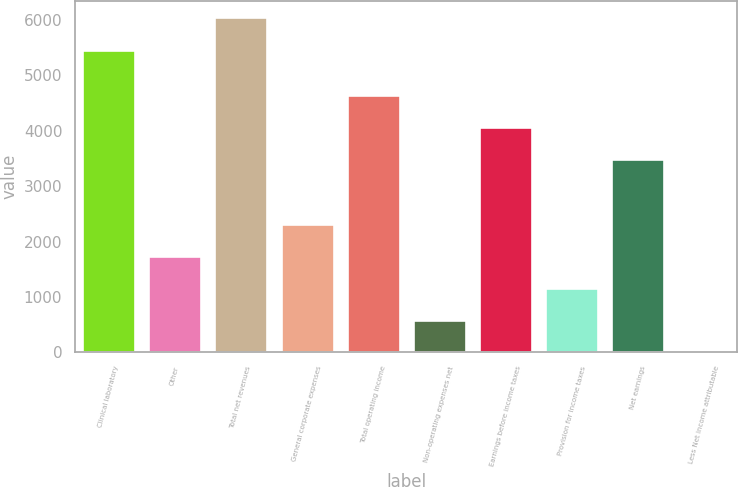Convert chart. <chart><loc_0><loc_0><loc_500><loc_500><bar_chart><fcel>Clinical laboratory<fcel>Other<fcel>Total net revenues<fcel>General corporate expenses<fcel>Total operating income<fcel>Non-operating expenses net<fcel>Earnings before income taxes<fcel>Provision for income taxes<fcel>Net earnings<fcel>Less Net income attributable<nl><fcel>5465.2<fcel>1743.61<fcel>6045.87<fcel>2324.28<fcel>4646.96<fcel>582.27<fcel>4066.29<fcel>1162.94<fcel>3485.62<fcel>1.6<nl></chart> 